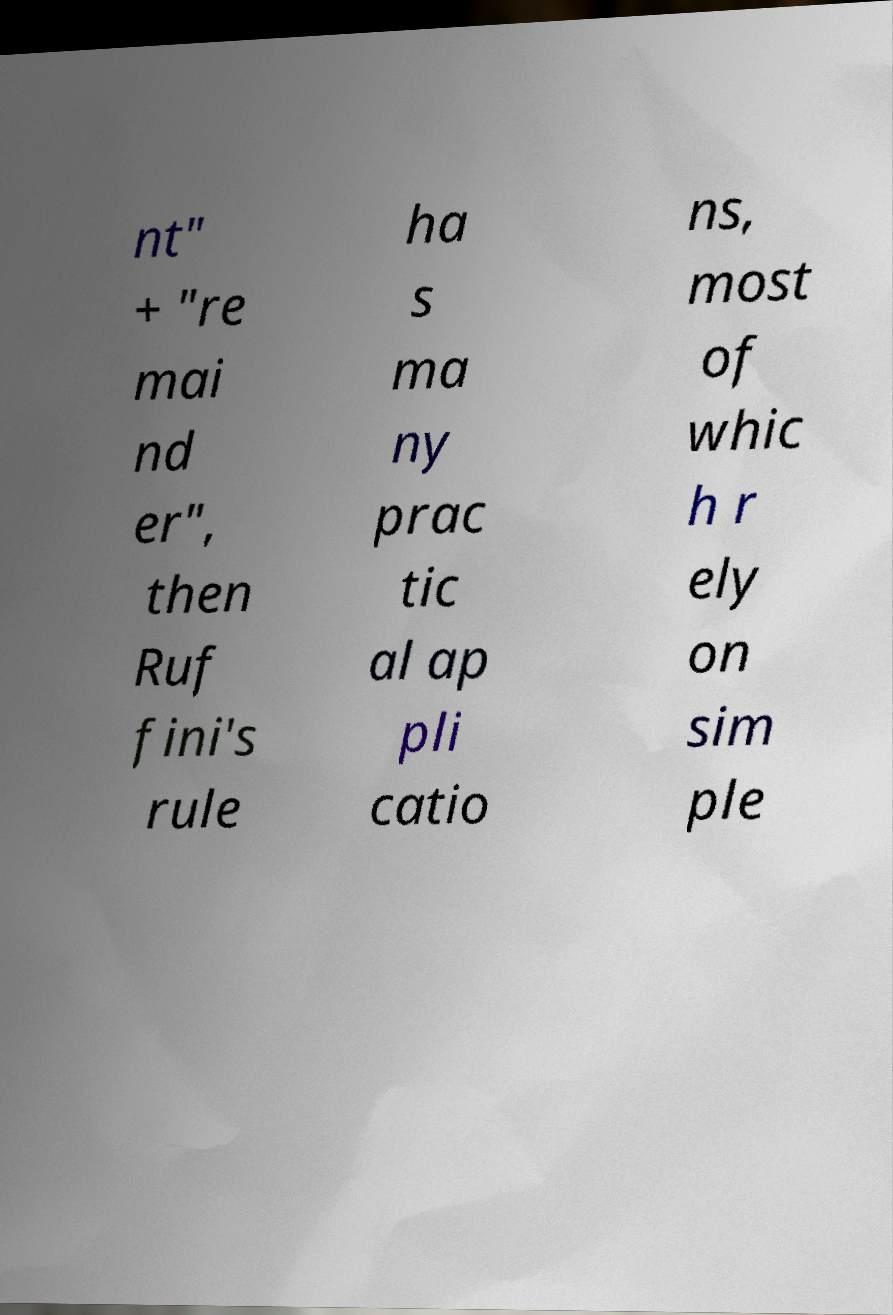Can you accurately transcribe the text from the provided image for me? nt" + "re mai nd er", then Ruf fini's rule ha s ma ny prac tic al ap pli catio ns, most of whic h r ely on sim ple 